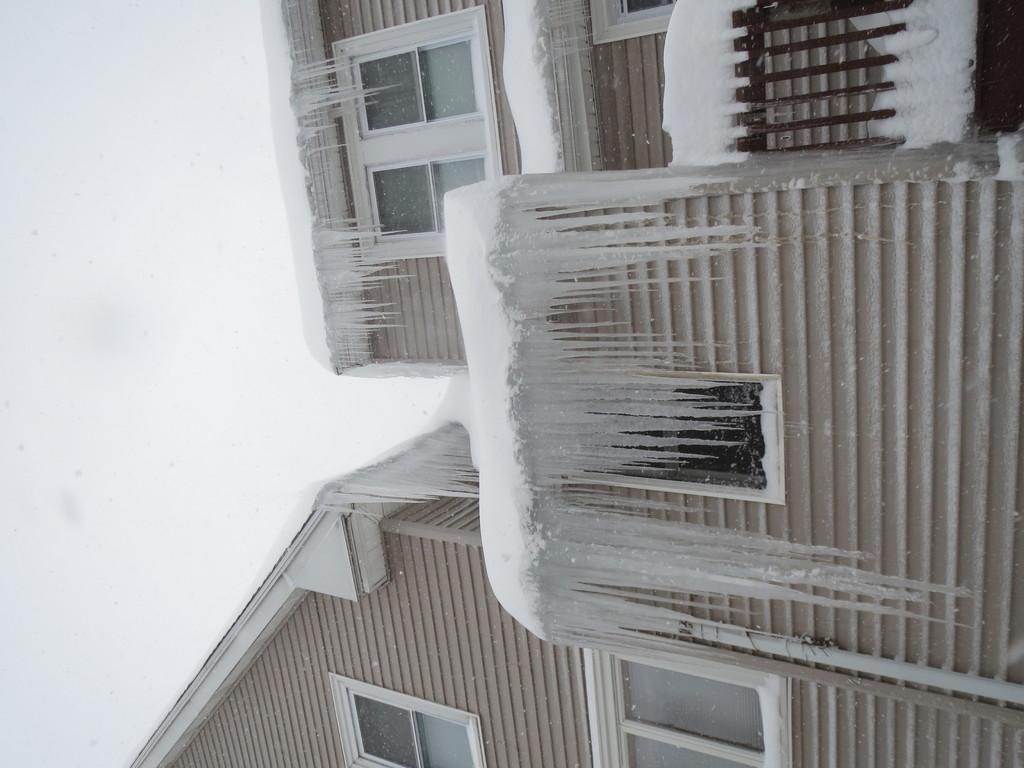What type of structures can be seen in the image? There are buildings in the image. What material are the windows of the buildings made of? The windows of the buildings are made of glass. What type of barrier is present in the image? There is a metal fence in the image. What weather condition is depicted in the image? Snow is present on the buildings and fence. What can be seen in the background of the image? The sky is visible in the background of the image. How many pigs can be seen in the image? There are no pigs present in the image. What type of vein is visible in the image? There is no vein visible in the image. 